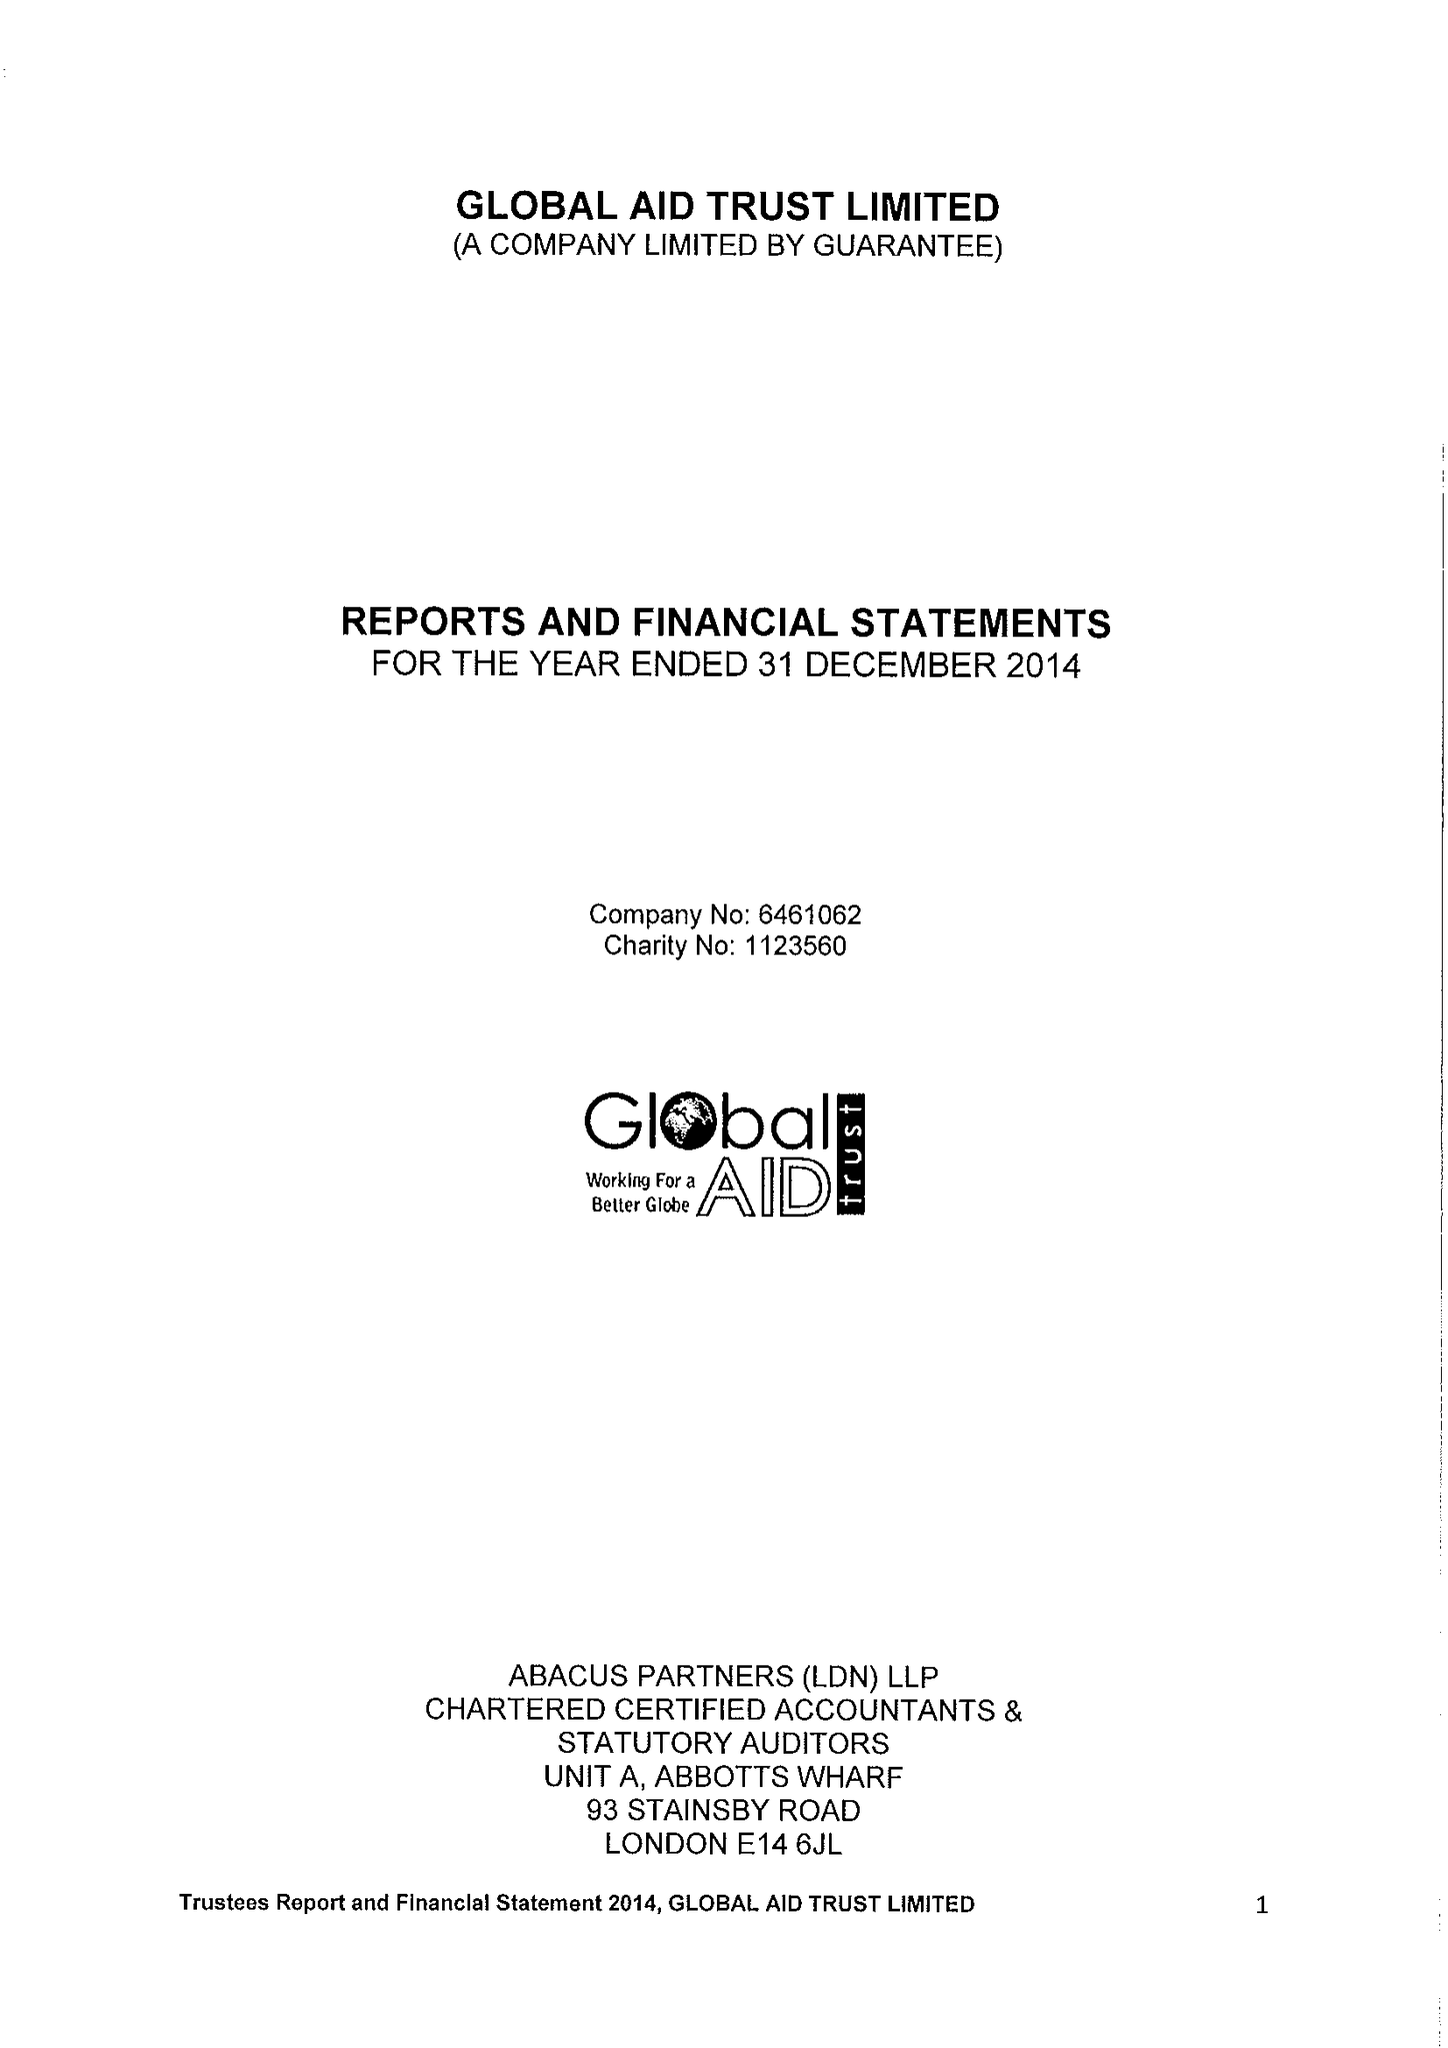What is the value for the spending_annually_in_british_pounds?
Answer the question using a single word or phrase. 754781.00 